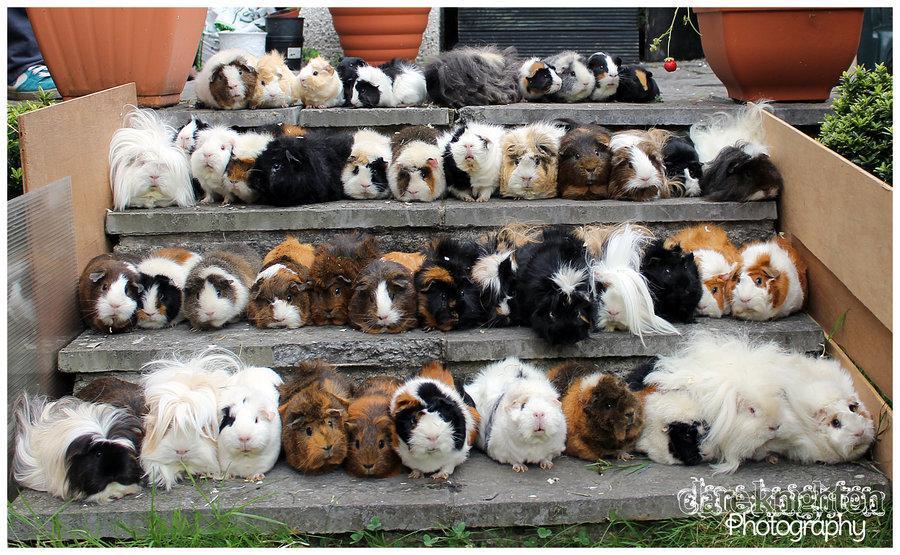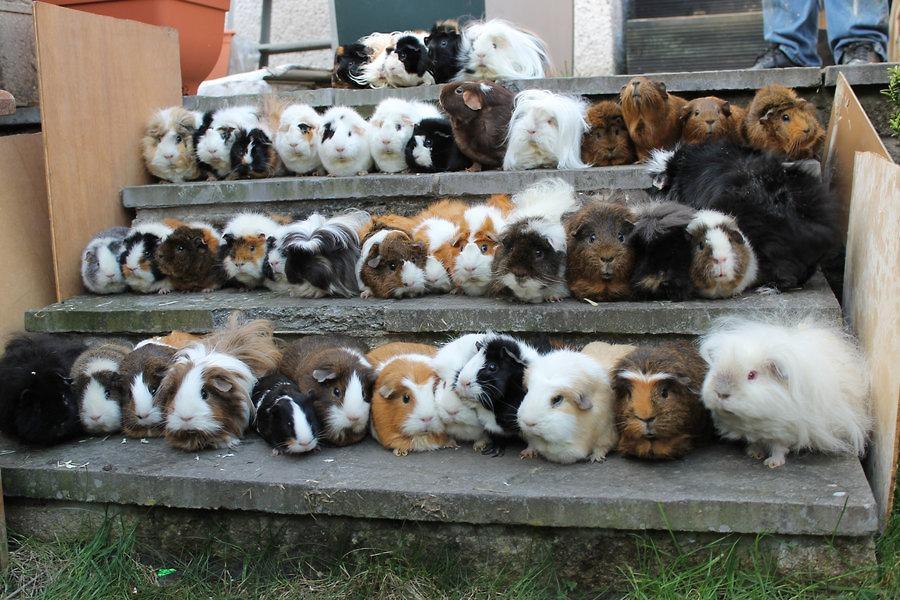The first image is the image on the left, the second image is the image on the right. For the images displayed, is the sentence "Some of the animals are sitting in a grassy area in one of the images." factually correct? Answer yes or no. No. 